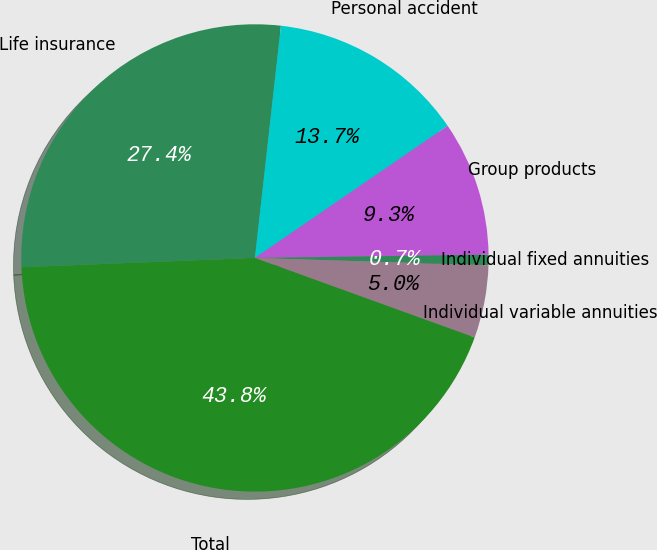<chart> <loc_0><loc_0><loc_500><loc_500><pie_chart><fcel>Life insurance<fcel>Personal accident<fcel>Group products<fcel>Individual fixed annuities<fcel>Individual variable annuities<fcel>Total<nl><fcel>27.41%<fcel>13.66%<fcel>9.34%<fcel>0.72%<fcel>5.03%<fcel>43.84%<nl></chart> 